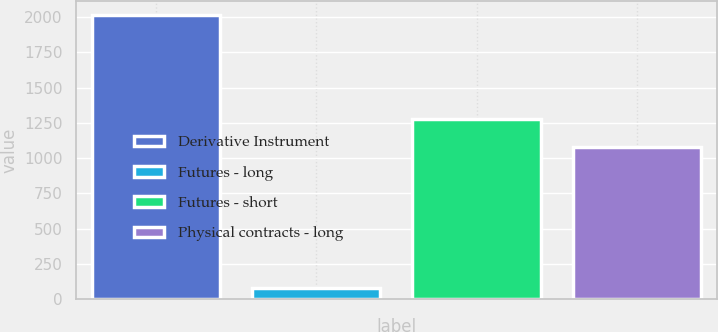<chart> <loc_0><loc_0><loc_500><loc_500><bar_chart><fcel>Derivative Instrument<fcel>Futures - long<fcel>Futures - short<fcel>Physical contracts - long<nl><fcel>2016<fcel>80<fcel>1274.6<fcel>1081<nl></chart> 